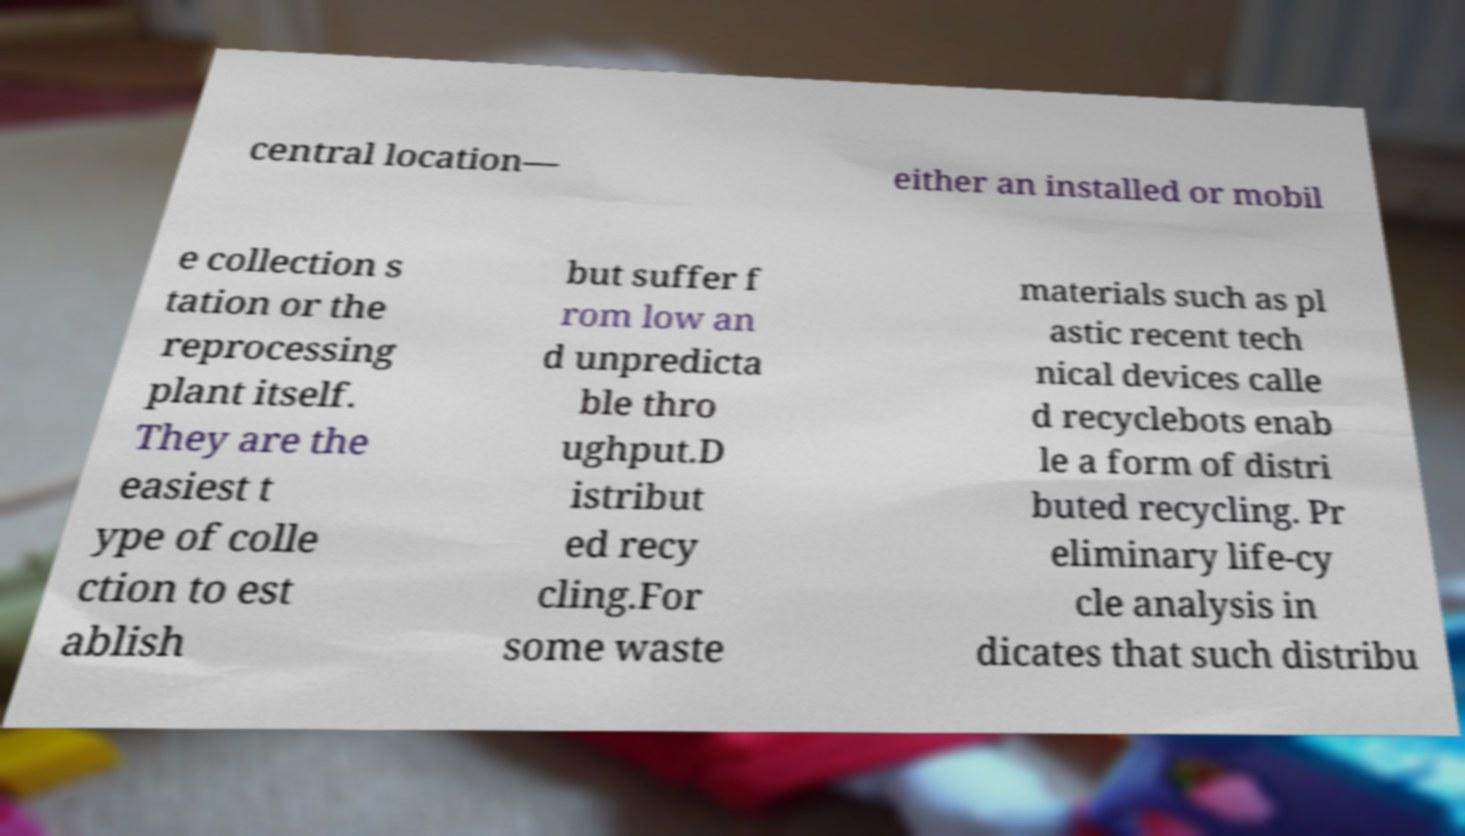What messages or text are displayed in this image? I need them in a readable, typed format. central location— either an installed or mobil e collection s tation or the reprocessing plant itself. They are the easiest t ype of colle ction to est ablish but suffer f rom low an d unpredicta ble thro ughput.D istribut ed recy cling.For some waste materials such as pl astic recent tech nical devices calle d recyclebots enab le a form of distri buted recycling. Pr eliminary life-cy cle analysis in dicates that such distribu 